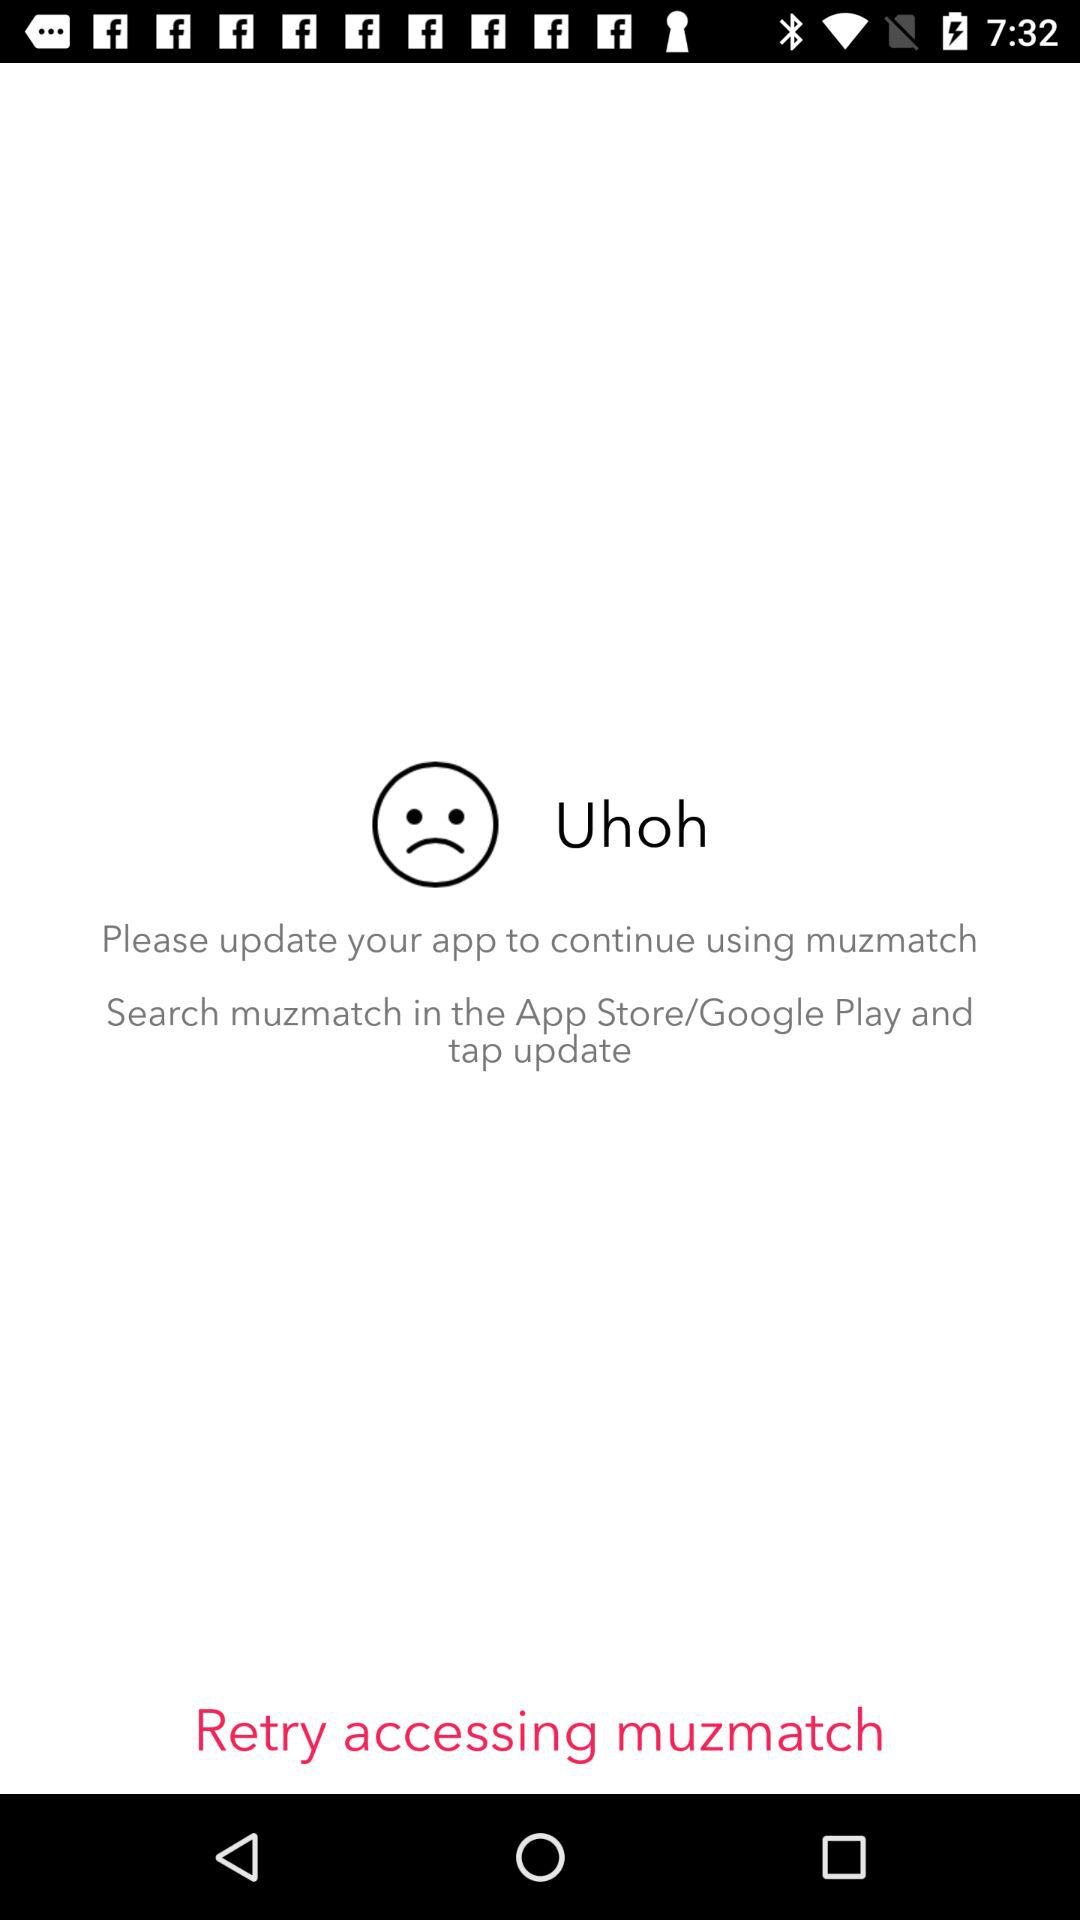What to do to continue using Muzmatch? To continue using Muzmatch, you have to update your app. 